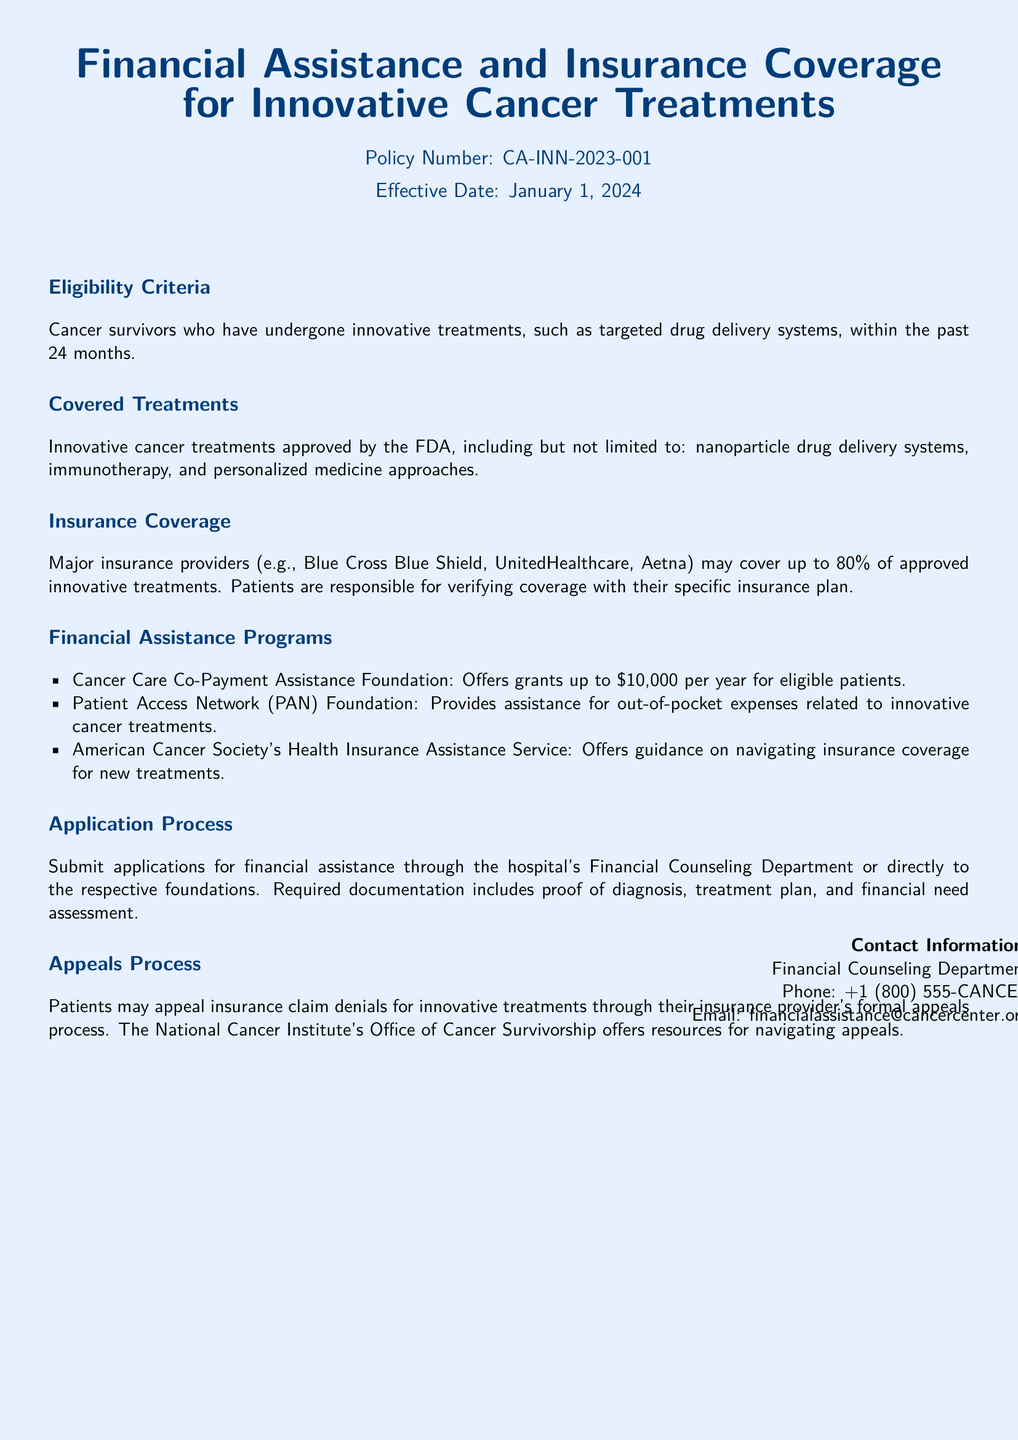What is the policy number? The policy number is mentioned at the beginning of the document.
Answer: CA-INN-2023-001 What treatments are covered? The section on covered treatments lists the types of treatments included.
Answer: FDA approved innovative cancer treatments What is the financial assistance limit offered by the Cancer Care Co-Payment Assistance Foundation? The financial assistance limit is specified in the financial assistance programs section.
Answer: $10,000 Which insurance providers are mentioned as covering treatments? The section on insurance coverage lists specific providers.
Answer: Blue Cross Blue Shield, UnitedHealthcare, Aetna What is the percentage of coverage provided by major insurance providers for innovative treatments? The insurance coverage section mentions the coverage percentage.
Answer: 80% How long should cancer survivors have undergone innovative treatments to be eligible? The eligibility criteria specifies the time frame for survivors.
Answer: 24 months What documentation is required for financial assistance applications? The application process section outlines necessary documentation.
Answer: Proof of diagnosis, treatment plan, and financial need assessment Who offers resources for navigating insurance claim denials? The appeals process section indicates where to find resources for appeals.
Answer: National Cancer Institute's Office of Cancer Survivorship 